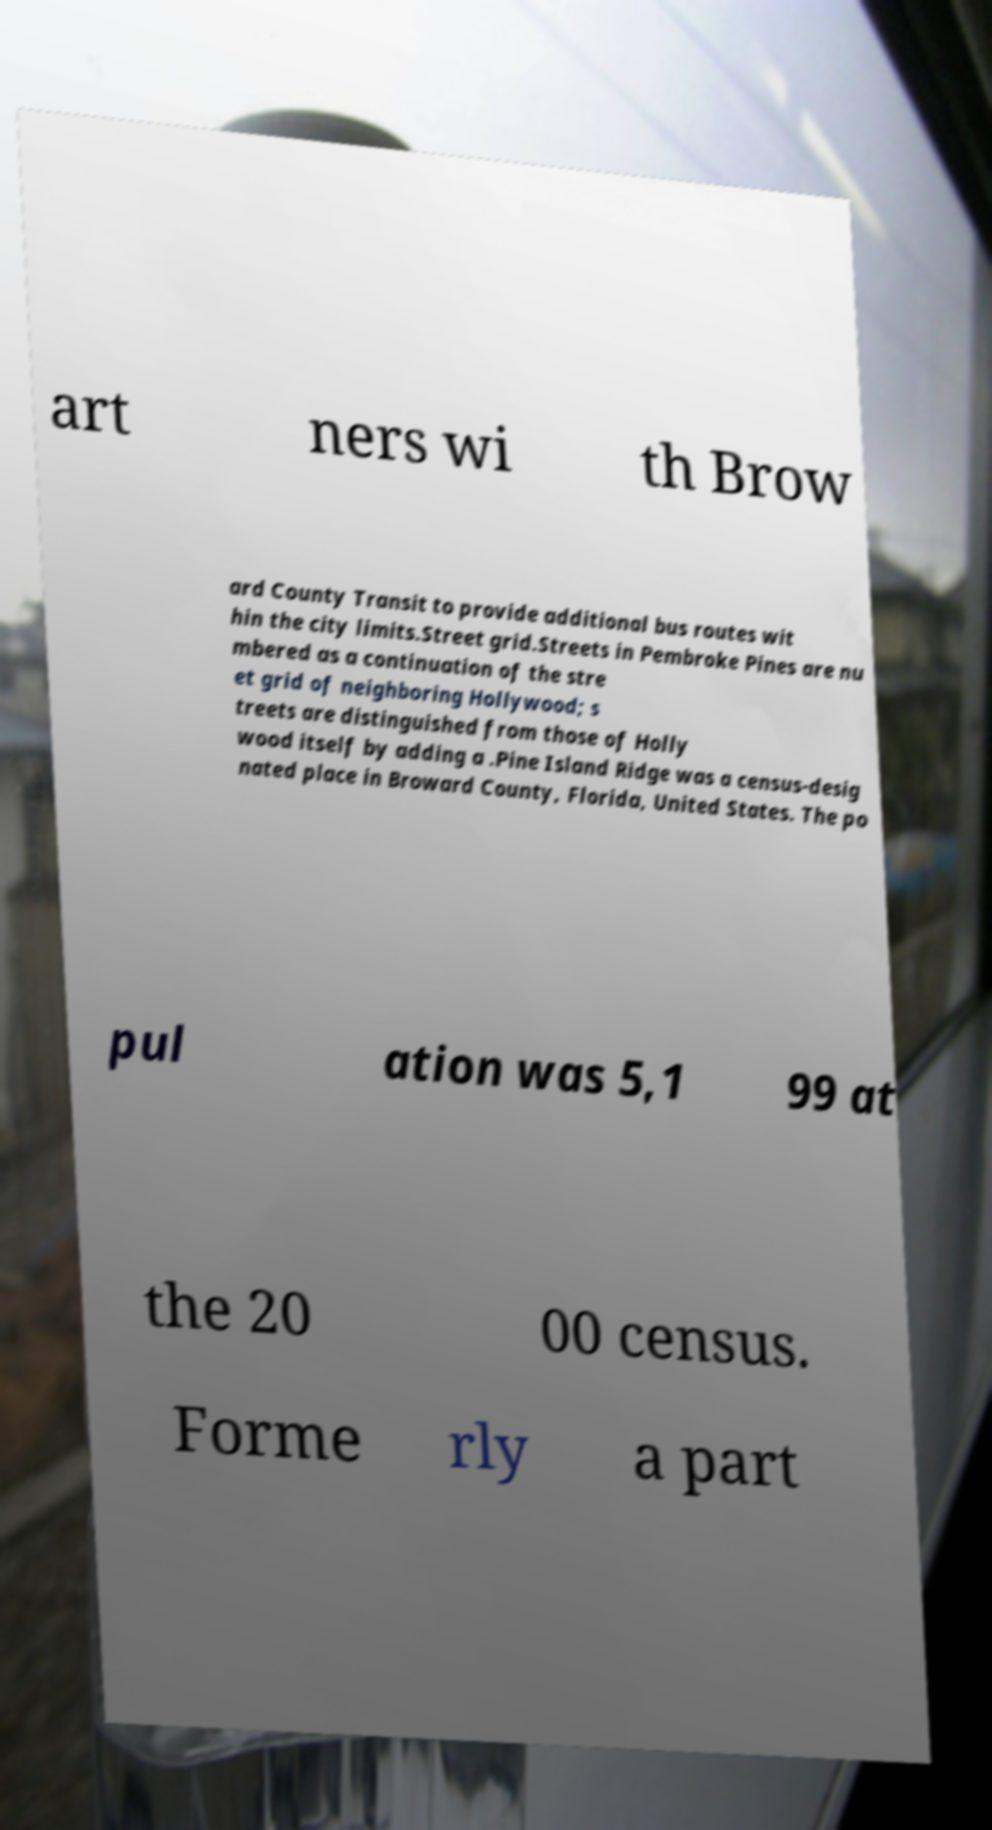I need the written content from this picture converted into text. Can you do that? art ners wi th Brow ard County Transit to provide additional bus routes wit hin the city limits.Street grid.Streets in Pembroke Pines are nu mbered as a continuation of the stre et grid of neighboring Hollywood; s treets are distinguished from those of Holly wood itself by adding a .Pine Island Ridge was a census-desig nated place in Broward County, Florida, United States. The po pul ation was 5,1 99 at the 20 00 census. Forme rly a part 